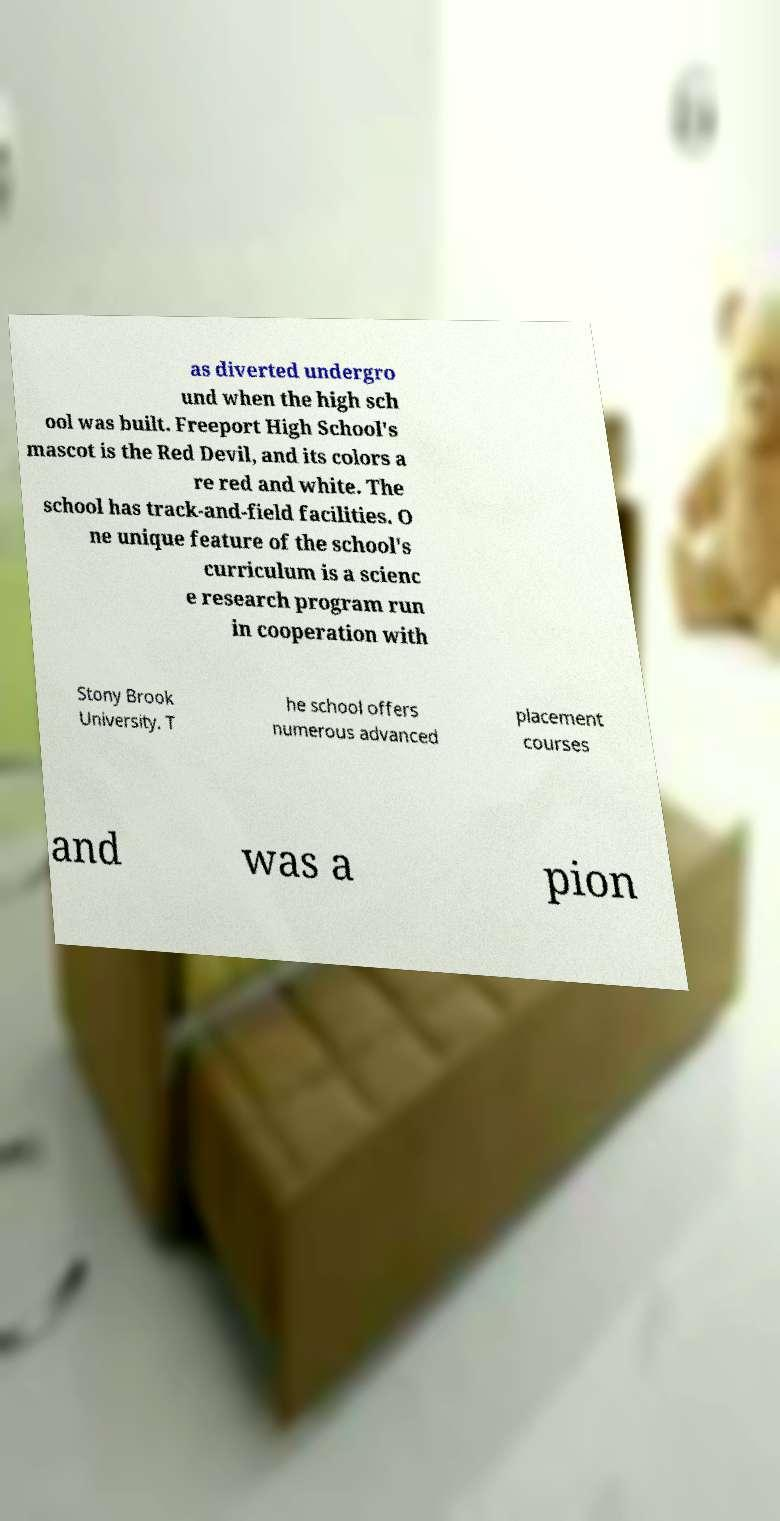Could you extract and type out the text from this image? as diverted undergro und when the high sch ool was built. Freeport High School's mascot is the Red Devil, and its colors a re red and white. The school has track-and-field facilities. O ne unique feature of the school's curriculum is a scienc e research program run in cooperation with Stony Brook University. T he school offers numerous advanced placement courses and was a pion 